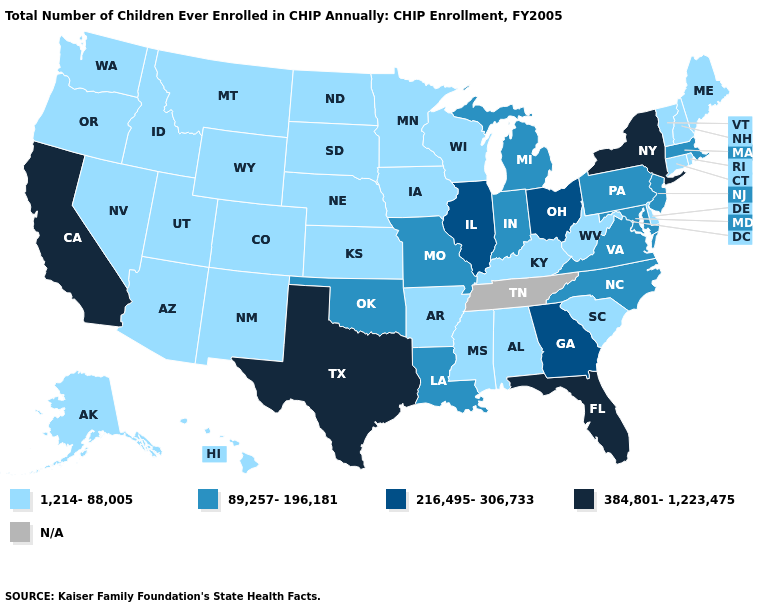How many symbols are there in the legend?
Answer briefly. 5. What is the highest value in the South ?
Give a very brief answer. 384,801-1,223,475. What is the value of North Dakota?
Quick response, please. 1,214-88,005. What is the value of New Jersey?
Give a very brief answer. 89,257-196,181. Among the states that border South Carolina , does Georgia have the lowest value?
Write a very short answer. No. What is the value of Washington?
Concise answer only. 1,214-88,005. Does Vermont have the highest value in the USA?
Be succinct. No. Which states have the lowest value in the West?
Write a very short answer. Alaska, Arizona, Colorado, Hawaii, Idaho, Montana, Nevada, New Mexico, Oregon, Utah, Washington, Wyoming. Does New Jersey have the highest value in the Northeast?
Be succinct. No. What is the lowest value in the USA?
Answer briefly. 1,214-88,005. What is the lowest value in the USA?
Answer briefly. 1,214-88,005. Does New Mexico have the highest value in the West?
Answer briefly. No. Does Vermont have the highest value in the Northeast?
Give a very brief answer. No. 